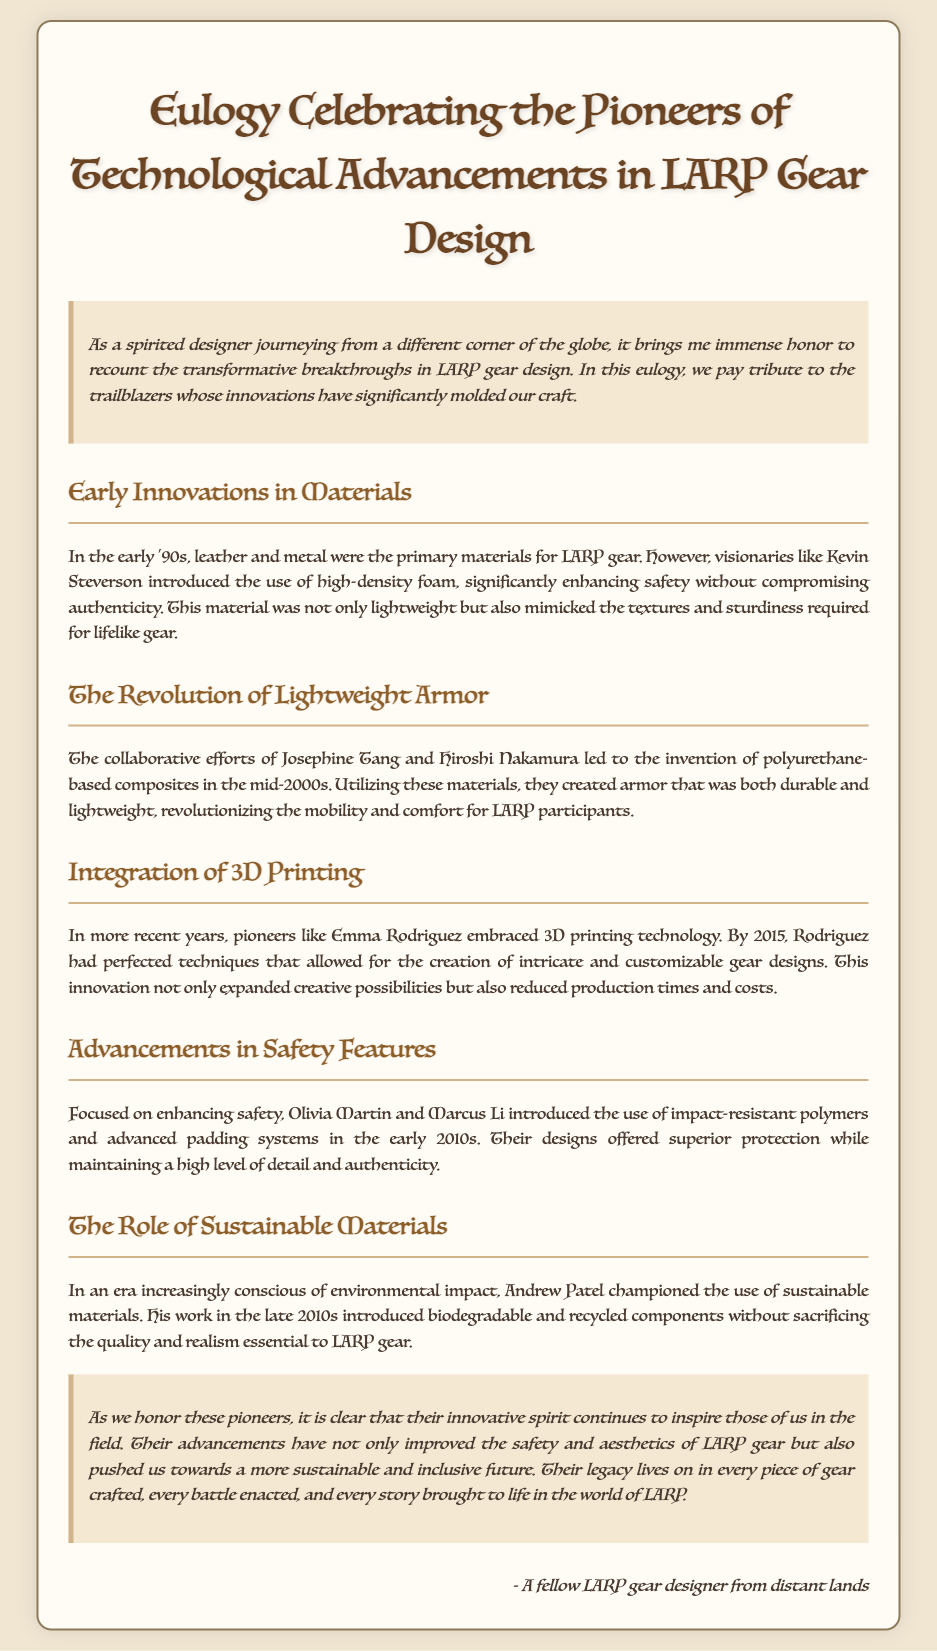what material did Kevin Steverson introduce? Kevin Steverson introduced high-density foam as a new material for LARP gear, enhancing safety without compromising authenticity.
Answer: high-density foam who collaborated with Josephine Tang on lightweight armor? The collaboration for the invention of lightweight armor was between Josephine Tang and Hiroshi Nakamura.
Answer: Hiroshi Nakamura what technology did Emma Rodriguez embrace? Emma Rodriguez embraced 3D printing technology which allowed for the creation of intricate and customizable gear designs.
Answer: 3D printing which sustainable champion introduced biodegradable materials? Andrew Patel championed the use of sustainable materials, including biodegradable ones, in LARP gear design.
Answer: Andrew Patel in what year did the integration of 3D printing take place? The integration of 3D printing technology in LARP gear design was perfected by Emma Rodriguez by the year 2015.
Answer: 2015 what was a major focus of Olivia Martin and Marcus Li’s innovation? Olivia Martin and Marcus Li focused on enhancing safety features in their LARP gear designs.
Answer: enhancing safety how did the introduction of polyurethane-based composites impact LARP gear? The introduction of polyurethane-based composites revolutionized the mobility and comfort for LARP participants.
Answer: mobility and comfort what problem does the use of recycled components address? The use of recycled components addresses environmental impact in LARP gear design.
Answer: environmental impact 